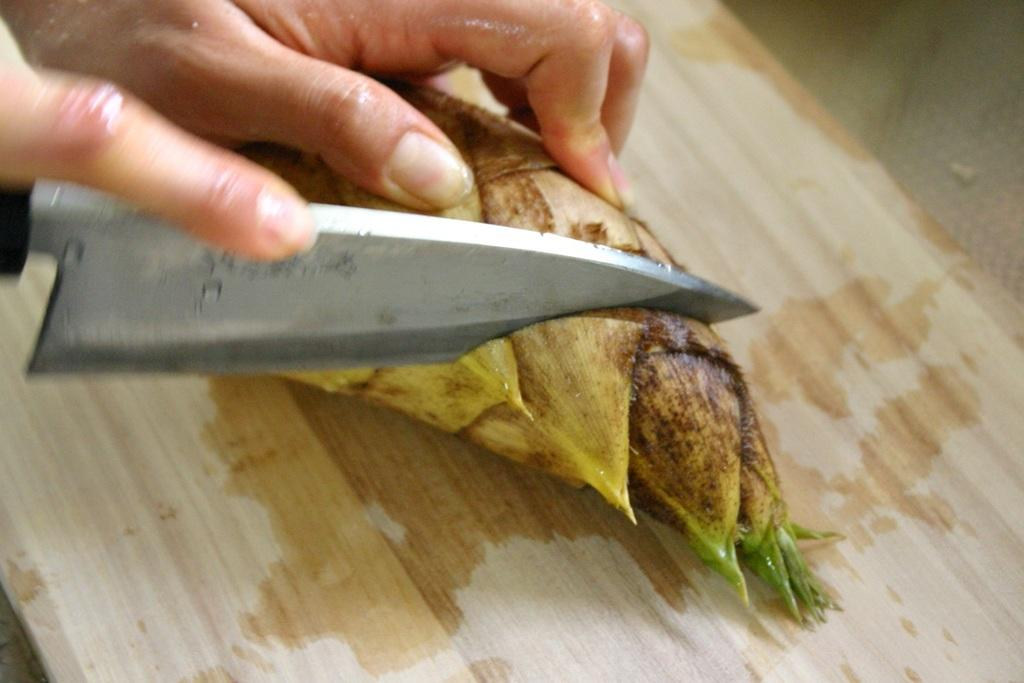What part of a person can be seen in the image? There is a person's hand in the image. What is the person's hand holding? The person's hand is holding a knife. What type of food is present in the image? There is a vegetable in the image. What is the vegetable placed on in the image? There is a chopping board in the image. What type of animal is sitting on the person's chin in the image? There is no animal present in the image, and the person's chin is not visible. 